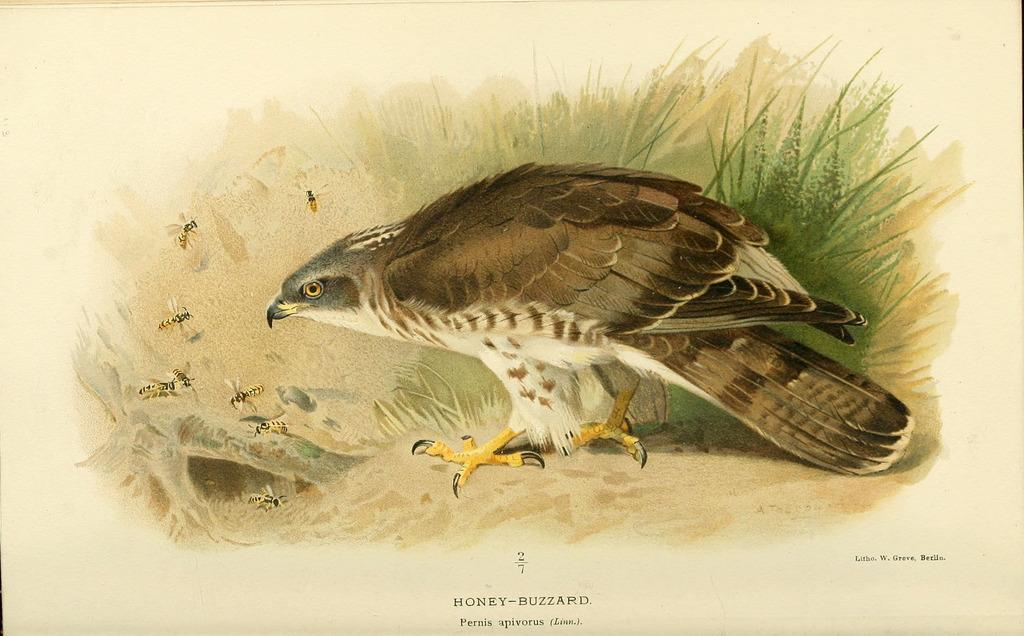What is the main subject of the image? There is a painting in the image. What is depicted in the painting? The painting depicts a bird, honey bees, and leaves. Is there any text associated with the painting in the image? Yes, there is text written below the painting. How many units of honey can be seen in the painting? There are no units of honey depicted in the painting; it features a bird, honey bees, and leaves. Is there a nest visible in the painting? There is no nest depicted in the painting; it features a bird, honey bees, and leaves. 